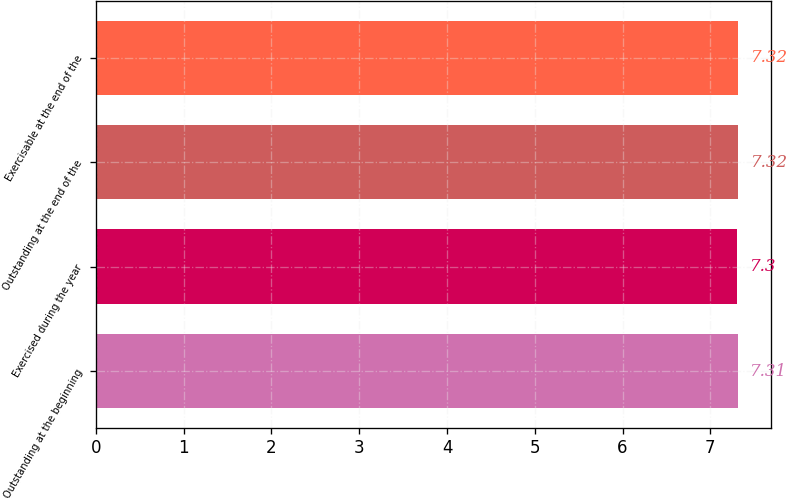<chart> <loc_0><loc_0><loc_500><loc_500><bar_chart><fcel>Outstanding at the beginning<fcel>Exercised during the year<fcel>Outstanding at the end of the<fcel>Exercisable at the end of the<nl><fcel>7.31<fcel>7.3<fcel>7.32<fcel>7.32<nl></chart> 